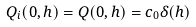<formula> <loc_0><loc_0><loc_500><loc_500>Q _ { i } ( 0 , h ) = Q ( 0 , h ) = c _ { 0 } \delta ( h )</formula> 